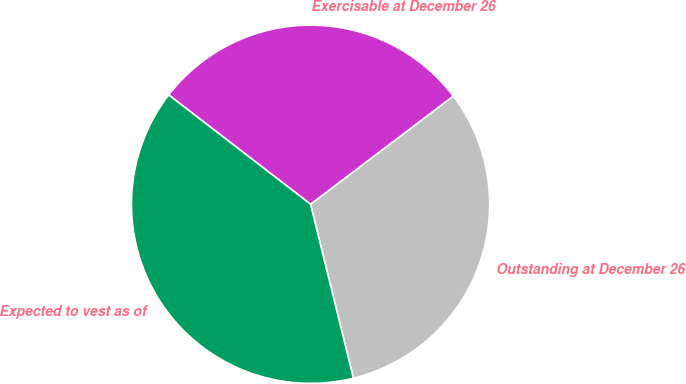Convert chart to OTSL. <chart><loc_0><loc_0><loc_500><loc_500><pie_chart><fcel>Outstanding at December 26<fcel>Exercisable at December 26<fcel>Expected to vest as of<nl><fcel>31.48%<fcel>29.23%<fcel>39.29%<nl></chart> 